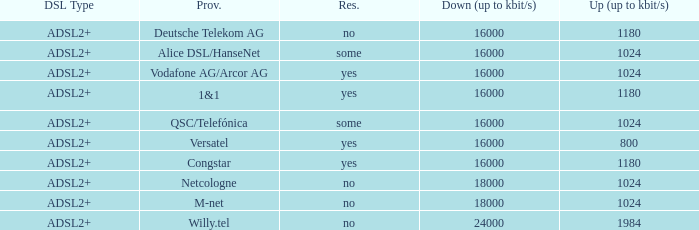What is download bandwith where the provider is deutsche telekom ag? 16000.0. 